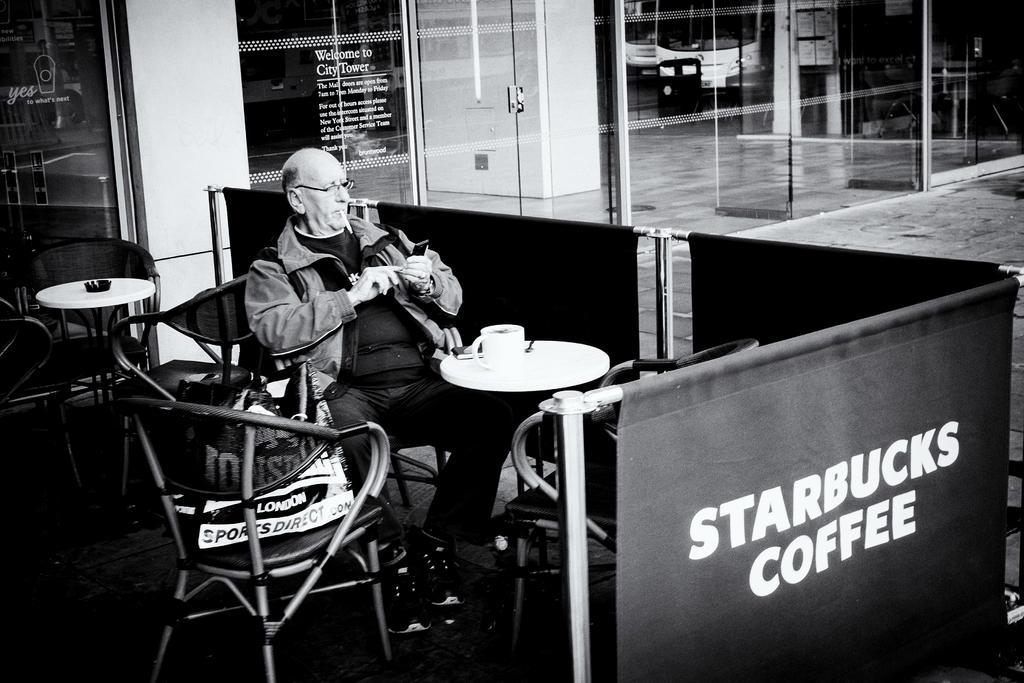In one or two sentences, can you explain what this image depicts? It looks like a black and white picture. We can see a man is sitting on a chair and holding a mobile and in front of the man there is a table and on the table there is a cup. Behind the man there are chairs, table, wall, glass door and other items. 